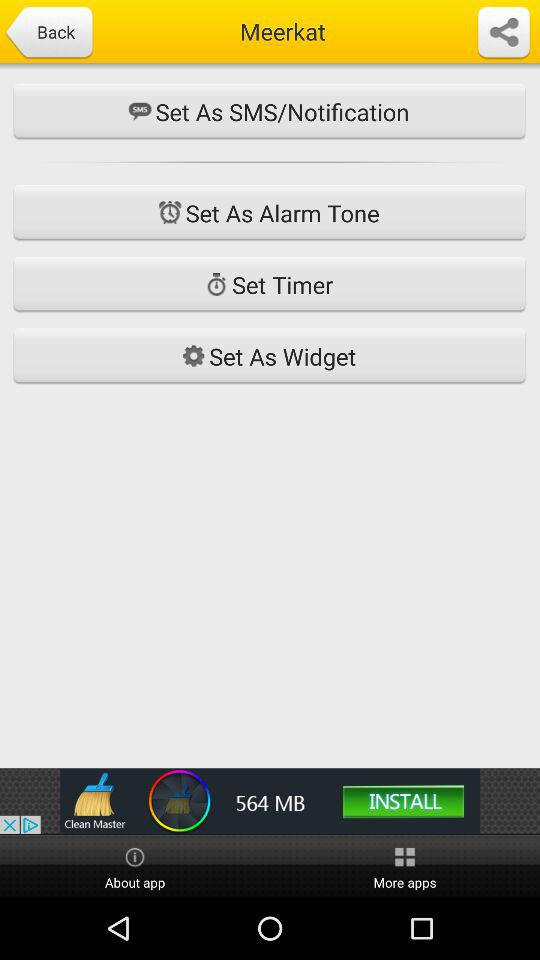What is the application name? The application name is "Meerkat". 